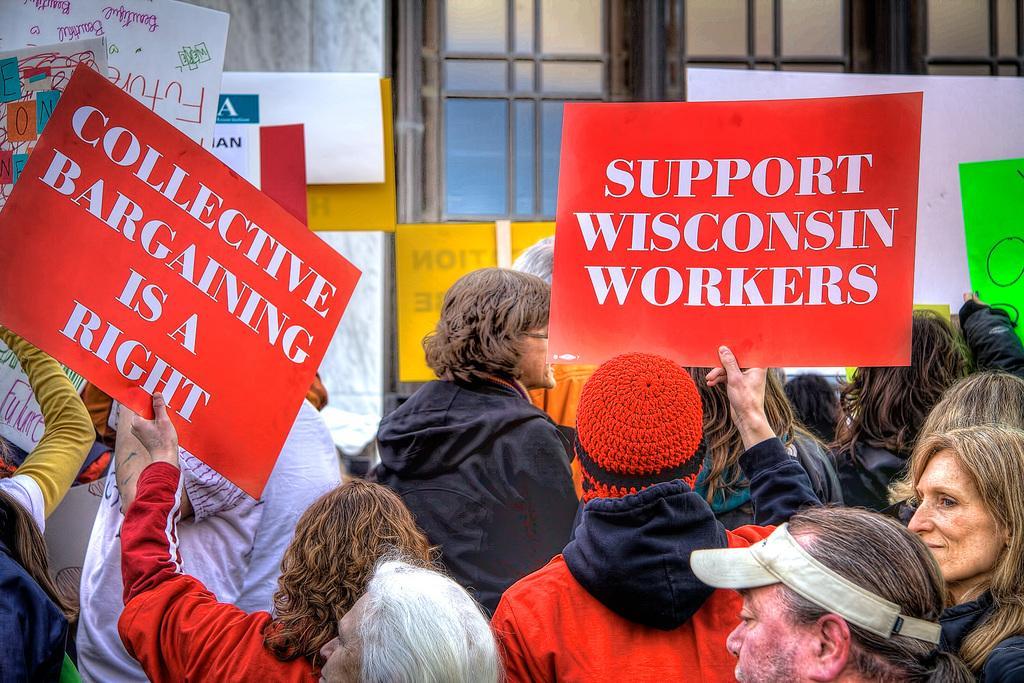In one or two sentences, can you explain what this image depicts? In this image, I can see a group of people standing. Among them few people are holding the boards in their hands. I think this is a window with the glass doors. I can see the letters written on the boards. 